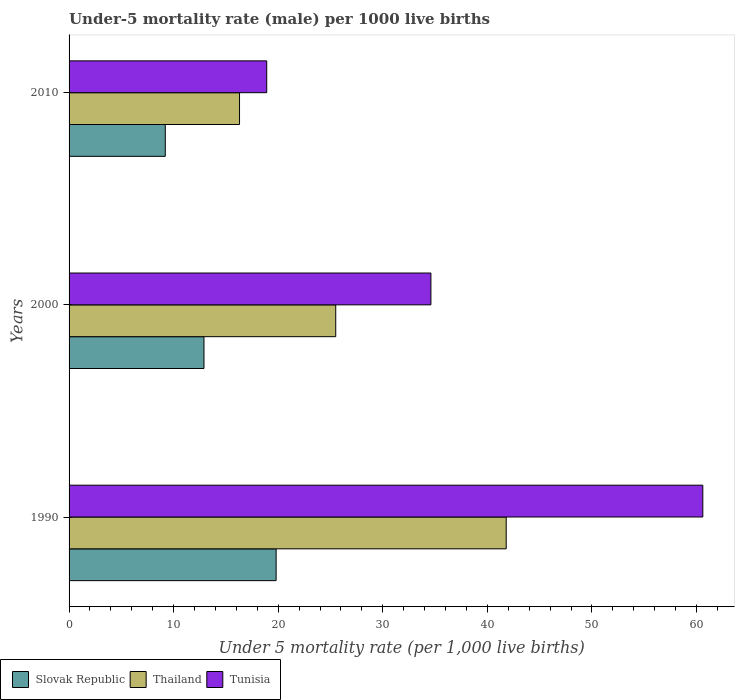How many different coloured bars are there?
Offer a very short reply. 3. Are the number of bars on each tick of the Y-axis equal?
Give a very brief answer. Yes. How many bars are there on the 2nd tick from the top?
Offer a very short reply. 3. How many bars are there on the 1st tick from the bottom?
Provide a short and direct response. 3. What is the under-five mortality rate in Slovak Republic in 1990?
Offer a very short reply. 19.8. Across all years, what is the maximum under-five mortality rate in Slovak Republic?
Give a very brief answer. 19.8. Across all years, what is the minimum under-five mortality rate in Slovak Republic?
Make the answer very short. 9.2. In which year was the under-five mortality rate in Tunisia maximum?
Provide a short and direct response. 1990. What is the total under-five mortality rate in Slovak Republic in the graph?
Your response must be concise. 41.9. What is the difference between the under-five mortality rate in Slovak Republic in 1990 and that in 2000?
Provide a short and direct response. 6.9. What is the difference between the under-five mortality rate in Thailand in 2010 and the under-five mortality rate in Slovak Republic in 2000?
Your answer should be very brief. 3.4. What is the average under-five mortality rate in Thailand per year?
Your answer should be compact. 27.87. In the year 2000, what is the difference between the under-five mortality rate in Slovak Republic and under-five mortality rate in Thailand?
Give a very brief answer. -12.6. What is the ratio of the under-five mortality rate in Thailand in 1990 to that in 2010?
Offer a terse response. 2.56. What is the difference between the highest and the second highest under-five mortality rate in Slovak Republic?
Keep it short and to the point. 6.9. What is the difference between the highest and the lowest under-five mortality rate in Tunisia?
Your answer should be compact. 41.7. What does the 1st bar from the top in 2010 represents?
Provide a short and direct response. Tunisia. What does the 1st bar from the bottom in 1990 represents?
Ensure brevity in your answer.  Slovak Republic. Is it the case that in every year, the sum of the under-five mortality rate in Thailand and under-five mortality rate in Tunisia is greater than the under-five mortality rate in Slovak Republic?
Offer a terse response. Yes. How many bars are there?
Offer a terse response. 9. What is the difference between two consecutive major ticks on the X-axis?
Provide a succinct answer. 10. Are the values on the major ticks of X-axis written in scientific E-notation?
Provide a short and direct response. No. Does the graph contain grids?
Ensure brevity in your answer.  No. Where does the legend appear in the graph?
Your response must be concise. Bottom left. How many legend labels are there?
Offer a terse response. 3. How are the legend labels stacked?
Make the answer very short. Horizontal. What is the title of the graph?
Offer a terse response. Under-5 mortality rate (male) per 1000 live births. Does "Korea (Republic)" appear as one of the legend labels in the graph?
Keep it short and to the point. No. What is the label or title of the X-axis?
Ensure brevity in your answer.  Under 5 mortality rate (per 1,0 live births). What is the label or title of the Y-axis?
Keep it short and to the point. Years. What is the Under 5 mortality rate (per 1,000 live births) of Slovak Republic in 1990?
Your answer should be very brief. 19.8. What is the Under 5 mortality rate (per 1,000 live births) of Thailand in 1990?
Offer a very short reply. 41.8. What is the Under 5 mortality rate (per 1,000 live births) in Tunisia in 1990?
Ensure brevity in your answer.  60.6. What is the Under 5 mortality rate (per 1,000 live births) in Slovak Republic in 2000?
Give a very brief answer. 12.9. What is the Under 5 mortality rate (per 1,000 live births) in Thailand in 2000?
Make the answer very short. 25.5. What is the Under 5 mortality rate (per 1,000 live births) in Tunisia in 2000?
Your answer should be compact. 34.6. What is the Under 5 mortality rate (per 1,000 live births) of Slovak Republic in 2010?
Your answer should be compact. 9.2. What is the Under 5 mortality rate (per 1,000 live births) of Thailand in 2010?
Make the answer very short. 16.3. What is the Under 5 mortality rate (per 1,000 live births) in Tunisia in 2010?
Your answer should be compact. 18.9. Across all years, what is the maximum Under 5 mortality rate (per 1,000 live births) of Slovak Republic?
Your response must be concise. 19.8. Across all years, what is the maximum Under 5 mortality rate (per 1,000 live births) in Thailand?
Make the answer very short. 41.8. Across all years, what is the maximum Under 5 mortality rate (per 1,000 live births) in Tunisia?
Your answer should be compact. 60.6. What is the total Under 5 mortality rate (per 1,000 live births) of Slovak Republic in the graph?
Your answer should be very brief. 41.9. What is the total Under 5 mortality rate (per 1,000 live births) of Thailand in the graph?
Ensure brevity in your answer.  83.6. What is the total Under 5 mortality rate (per 1,000 live births) of Tunisia in the graph?
Your answer should be very brief. 114.1. What is the difference between the Under 5 mortality rate (per 1,000 live births) in Thailand in 1990 and that in 2010?
Provide a succinct answer. 25.5. What is the difference between the Under 5 mortality rate (per 1,000 live births) in Tunisia in 1990 and that in 2010?
Your answer should be compact. 41.7. What is the difference between the Under 5 mortality rate (per 1,000 live births) in Thailand in 2000 and that in 2010?
Keep it short and to the point. 9.2. What is the difference between the Under 5 mortality rate (per 1,000 live births) of Tunisia in 2000 and that in 2010?
Give a very brief answer. 15.7. What is the difference between the Under 5 mortality rate (per 1,000 live births) in Slovak Republic in 1990 and the Under 5 mortality rate (per 1,000 live births) in Tunisia in 2000?
Provide a short and direct response. -14.8. What is the difference between the Under 5 mortality rate (per 1,000 live births) of Thailand in 1990 and the Under 5 mortality rate (per 1,000 live births) of Tunisia in 2000?
Your response must be concise. 7.2. What is the difference between the Under 5 mortality rate (per 1,000 live births) of Thailand in 1990 and the Under 5 mortality rate (per 1,000 live births) of Tunisia in 2010?
Your response must be concise. 22.9. What is the difference between the Under 5 mortality rate (per 1,000 live births) in Slovak Republic in 2000 and the Under 5 mortality rate (per 1,000 live births) in Thailand in 2010?
Give a very brief answer. -3.4. What is the average Under 5 mortality rate (per 1,000 live births) in Slovak Republic per year?
Offer a terse response. 13.97. What is the average Under 5 mortality rate (per 1,000 live births) of Thailand per year?
Your response must be concise. 27.87. What is the average Under 5 mortality rate (per 1,000 live births) in Tunisia per year?
Your answer should be compact. 38.03. In the year 1990, what is the difference between the Under 5 mortality rate (per 1,000 live births) of Slovak Republic and Under 5 mortality rate (per 1,000 live births) of Tunisia?
Your response must be concise. -40.8. In the year 1990, what is the difference between the Under 5 mortality rate (per 1,000 live births) in Thailand and Under 5 mortality rate (per 1,000 live births) in Tunisia?
Provide a succinct answer. -18.8. In the year 2000, what is the difference between the Under 5 mortality rate (per 1,000 live births) of Slovak Republic and Under 5 mortality rate (per 1,000 live births) of Thailand?
Make the answer very short. -12.6. In the year 2000, what is the difference between the Under 5 mortality rate (per 1,000 live births) in Slovak Republic and Under 5 mortality rate (per 1,000 live births) in Tunisia?
Your answer should be compact. -21.7. In the year 2000, what is the difference between the Under 5 mortality rate (per 1,000 live births) of Thailand and Under 5 mortality rate (per 1,000 live births) of Tunisia?
Provide a short and direct response. -9.1. In the year 2010, what is the difference between the Under 5 mortality rate (per 1,000 live births) of Slovak Republic and Under 5 mortality rate (per 1,000 live births) of Thailand?
Offer a terse response. -7.1. In the year 2010, what is the difference between the Under 5 mortality rate (per 1,000 live births) of Thailand and Under 5 mortality rate (per 1,000 live births) of Tunisia?
Make the answer very short. -2.6. What is the ratio of the Under 5 mortality rate (per 1,000 live births) in Slovak Republic in 1990 to that in 2000?
Ensure brevity in your answer.  1.53. What is the ratio of the Under 5 mortality rate (per 1,000 live births) in Thailand in 1990 to that in 2000?
Provide a short and direct response. 1.64. What is the ratio of the Under 5 mortality rate (per 1,000 live births) of Tunisia in 1990 to that in 2000?
Give a very brief answer. 1.75. What is the ratio of the Under 5 mortality rate (per 1,000 live births) in Slovak Republic in 1990 to that in 2010?
Your response must be concise. 2.15. What is the ratio of the Under 5 mortality rate (per 1,000 live births) in Thailand in 1990 to that in 2010?
Give a very brief answer. 2.56. What is the ratio of the Under 5 mortality rate (per 1,000 live births) of Tunisia in 1990 to that in 2010?
Make the answer very short. 3.21. What is the ratio of the Under 5 mortality rate (per 1,000 live births) of Slovak Republic in 2000 to that in 2010?
Provide a short and direct response. 1.4. What is the ratio of the Under 5 mortality rate (per 1,000 live births) of Thailand in 2000 to that in 2010?
Ensure brevity in your answer.  1.56. What is the ratio of the Under 5 mortality rate (per 1,000 live births) of Tunisia in 2000 to that in 2010?
Give a very brief answer. 1.83. What is the difference between the highest and the second highest Under 5 mortality rate (per 1,000 live births) of Slovak Republic?
Offer a terse response. 6.9. What is the difference between the highest and the second highest Under 5 mortality rate (per 1,000 live births) of Tunisia?
Keep it short and to the point. 26. What is the difference between the highest and the lowest Under 5 mortality rate (per 1,000 live births) of Tunisia?
Offer a terse response. 41.7. 